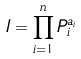<formula> <loc_0><loc_0><loc_500><loc_500>I = \prod _ { i = 1 } ^ { n } P _ { i } ^ { a _ { i } }</formula> 